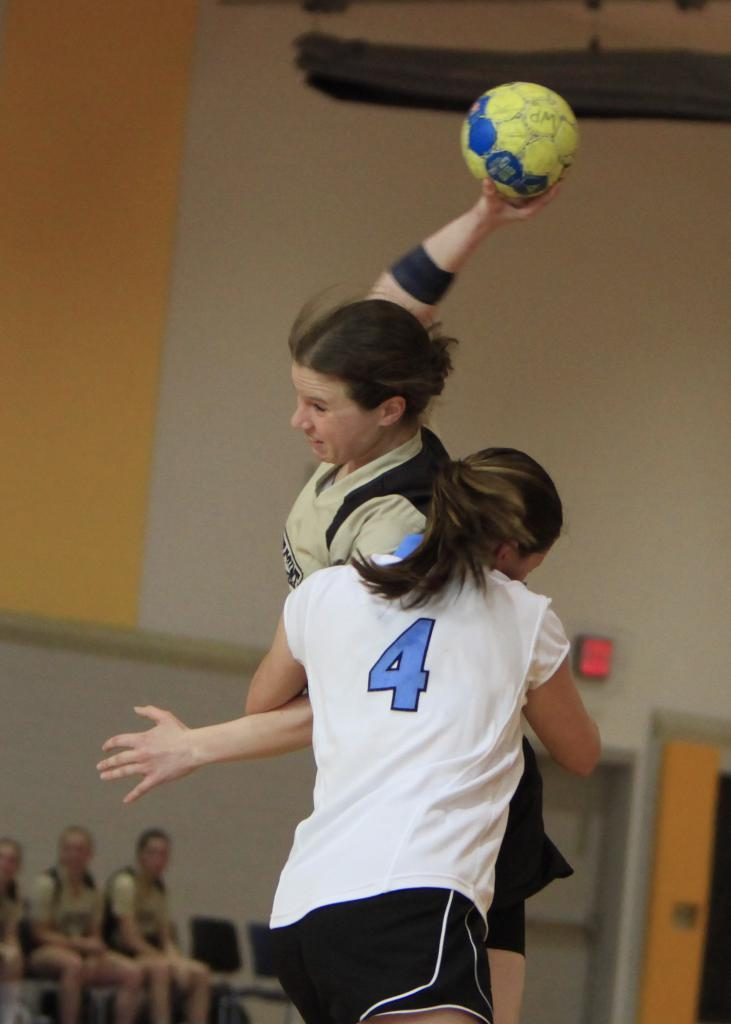<image>
Give a short and clear explanation of the subsequent image. a girl with a white shirt that has the number 4 